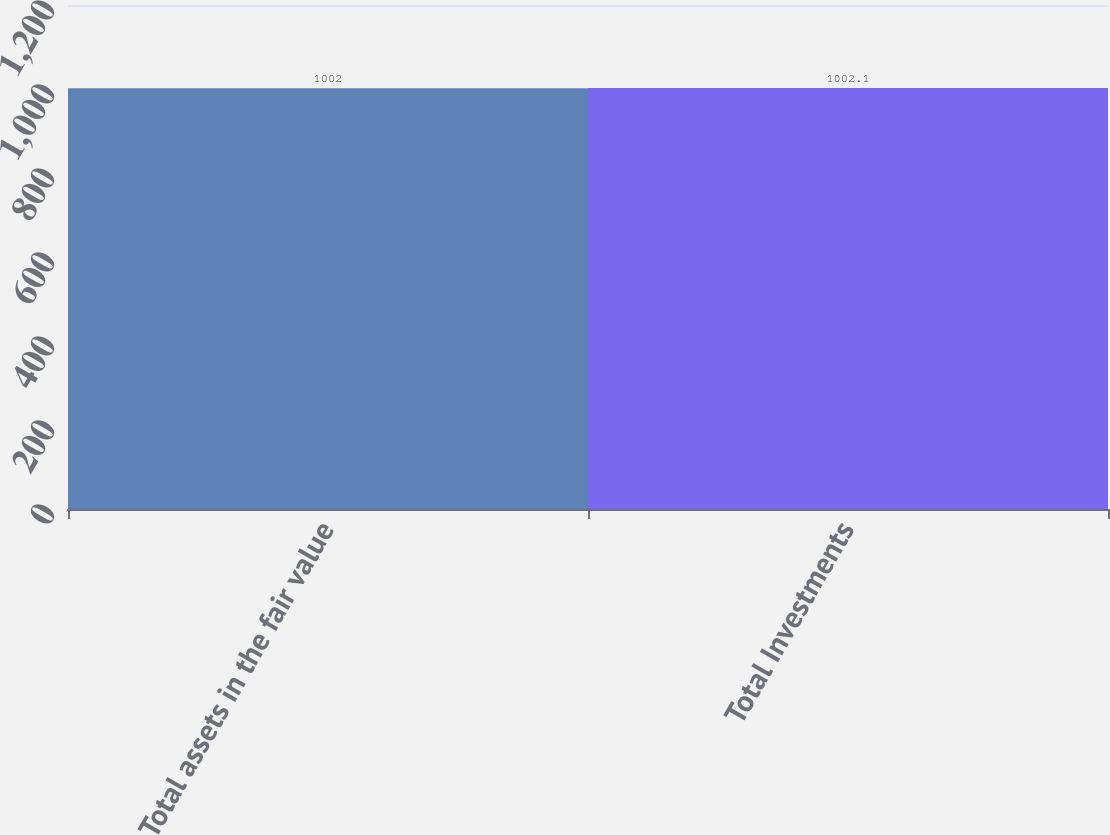<chart> <loc_0><loc_0><loc_500><loc_500><bar_chart><fcel>Total assets in the fair value<fcel>Total Investments<nl><fcel>1002<fcel>1002.1<nl></chart> 